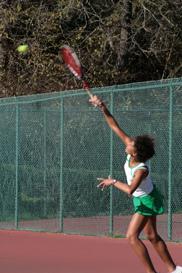What trajectory is the ball heading?
Be succinct. Down. What is she about to hit?
Give a very brief answer. Tennis ball. Is she wearing a tennis outfit?
Give a very brief answer. Yes. Is she hitting something?
Quick response, please. Yes. What race is the lady?
Keep it brief. Black. Why is she wearing her hair up?
Short answer required. Playing tennis. What color is her hair?
Keep it brief. Black. 